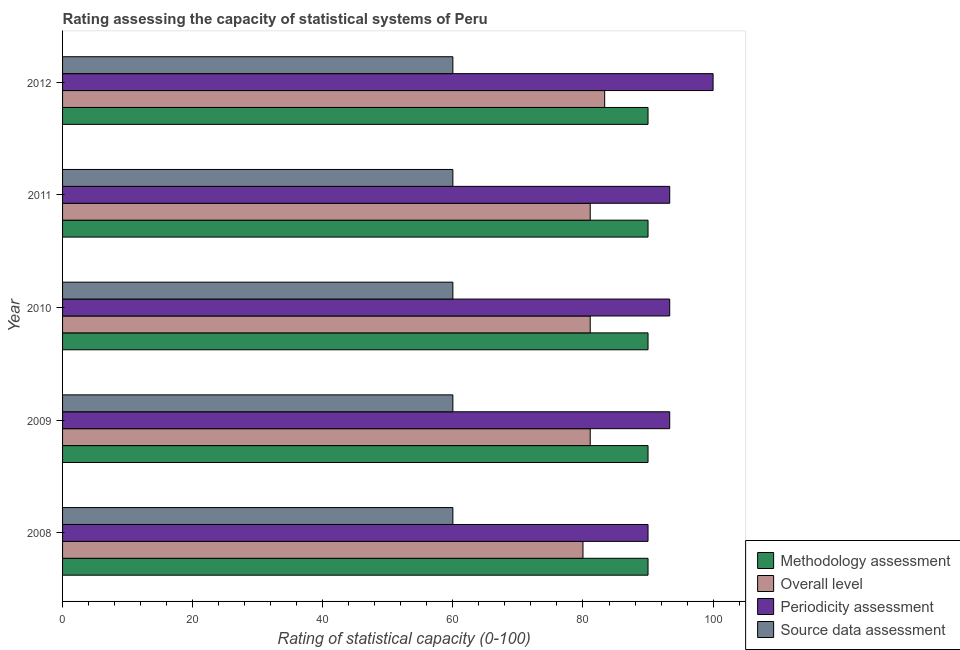How many groups of bars are there?
Ensure brevity in your answer.  5. Are the number of bars per tick equal to the number of legend labels?
Provide a short and direct response. Yes. How many bars are there on the 2nd tick from the top?
Ensure brevity in your answer.  4. How many bars are there on the 4th tick from the bottom?
Ensure brevity in your answer.  4. Across all years, what is the maximum methodology assessment rating?
Your response must be concise. 90. Across all years, what is the minimum methodology assessment rating?
Provide a succinct answer. 90. In which year was the overall level rating minimum?
Your response must be concise. 2008. What is the total periodicity assessment rating in the graph?
Offer a very short reply. 470. What is the difference between the methodology assessment rating in 2009 and that in 2012?
Make the answer very short. 0. What is the difference between the source data assessment rating in 2011 and the periodicity assessment rating in 2009?
Give a very brief answer. -33.33. In the year 2009, what is the difference between the periodicity assessment rating and overall level rating?
Your answer should be very brief. 12.22. What is the ratio of the overall level rating in 2010 to that in 2011?
Provide a short and direct response. 1. What is the difference between the highest and the second highest overall level rating?
Your answer should be very brief. 2.22. What is the difference between the highest and the lowest periodicity assessment rating?
Give a very brief answer. 10. In how many years, is the overall level rating greater than the average overall level rating taken over all years?
Keep it short and to the point. 1. Is the sum of the overall level rating in 2008 and 2011 greater than the maximum periodicity assessment rating across all years?
Your answer should be compact. Yes. What does the 3rd bar from the top in 2012 represents?
Provide a short and direct response. Overall level. What does the 2nd bar from the bottom in 2011 represents?
Offer a very short reply. Overall level. How many bars are there?
Ensure brevity in your answer.  20. Are all the bars in the graph horizontal?
Your answer should be very brief. Yes. What is the difference between two consecutive major ticks on the X-axis?
Keep it short and to the point. 20. Does the graph contain grids?
Your response must be concise. No. How many legend labels are there?
Offer a terse response. 4. What is the title of the graph?
Offer a terse response. Rating assessing the capacity of statistical systems of Peru. What is the label or title of the X-axis?
Give a very brief answer. Rating of statistical capacity (0-100). What is the label or title of the Y-axis?
Offer a terse response. Year. What is the Rating of statistical capacity (0-100) in Overall level in 2008?
Your answer should be compact. 80. What is the Rating of statistical capacity (0-100) of Periodicity assessment in 2008?
Your answer should be compact. 90. What is the Rating of statistical capacity (0-100) of Methodology assessment in 2009?
Provide a short and direct response. 90. What is the Rating of statistical capacity (0-100) of Overall level in 2009?
Give a very brief answer. 81.11. What is the Rating of statistical capacity (0-100) of Periodicity assessment in 2009?
Your answer should be very brief. 93.33. What is the Rating of statistical capacity (0-100) in Source data assessment in 2009?
Your response must be concise. 60. What is the Rating of statistical capacity (0-100) in Overall level in 2010?
Offer a terse response. 81.11. What is the Rating of statistical capacity (0-100) in Periodicity assessment in 2010?
Provide a short and direct response. 93.33. What is the Rating of statistical capacity (0-100) in Source data assessment in 2010?
Your response must be concise. 60. What is the Rating of statistical capacity (0-100) of Methodology assessment in 2011?
Offer a terse response. 90. What is the Rating of statistical capacity (0-100) of Overall level in 2011?
Offer a very short reply. 81.11. What is the Rating of statistical capacity (0-100) of Periodicity assessment in 2011?
Give a very brief answer. 93.33. What is the Rating of statistical capacity (0-100) of Source data assessment in 2011?
Give a very brief answer. 60. What is the Rating of statistical capacity (0-100) of Methodology assessment in 2012?
Give a very brief answer. 90. What is the Rating of statistical capacity (0-100) in Overall level in 2012?
Your answer should be compact. 83.33. What is the Rating of statistical capacity (0-100) of Periodicity assessment in 2012?
Your answer should be compact. 100. Across all years, what is the maximum Rating of statistical capacity (0-100) of Methodology assessment?
Give a very brief answer. 90. Across all years, what is the maximum Rating of statistical capacity (0-100) in Overall level?
Keep it short and to the point. 83.33. Across all years, what is the maximum Rating of statistical capacity (0-100) of Periodicity assessment?
Offer a very short reply. 100. Across all years, what is the maximum Rating of statistical capacity (0-100) in Source data assessment?
Keep it short and to the point. 60. Across all years, what is the minimum Rating of statistical capacity (0-100) in Periodicity assessment?
Offer a very short reply. 90. What is the total Rating of statistical capacity (0-100) in Methodology assessment in the graph?
Offer a very short reply. 450. What is the total Rating of statistical capacity (0-100) in Overall level in the graph?
Make the answer very short. 406.67. What is the total Rating of statistical capacity (0-100) in Periodicity assessment in the graph?
Offer a very short reply. 470. What is the total Rating of statistical capacity (0-100) of Source data assessment in the graph?
Your answer should be very brief. 300. What is the difference between the Rating of statistical capacity (0-100) of Overall level in 2008 and that in 2009?
Your answer should be compact. -1.11. What is the difference between the Rating of statistical capacity (0-100) of Periodicity assessment in 2008 and that in 2009?
Your answer should be very brief. -3.33. What is the difference between the Rating of statistical capacity (0-100) of Methodology assessment in 2008 and that in 2010?
Provide a succinct answer. 0. What is the difference between the Rating of statistical capacity (0-100) in Overall level in 2008 and that in 2010?
Offer a very short reply. -1.11. What is the difference between the Rating of statistical capacity (0-100) of Overall level in 2008 and that in 2011?
Offer a very short reply. -1.11. What is the difference between the Rating of statistical capacity (0-100) in Periodicity assessment in 2008 and that in 2011?
Your answer should be compact. -3.33. What is the difference between the Rating of statistical capacity (0-100) of Methodology assessment in 2008 and that in 2012?
Provide a succinct answer. 0. What is the difference between the Rating of statistical capacity (0-100) of Overall level in 2008 and that in 2012?
Provide a succinct answer. -3.33. What is the difference between the Rating of statistical capacity (0-100) in Periodicity assessment in 2008 and that in 2012?
Make the answer very short. -10. What is the difference between the Rating of statistical capacity (0-100) in Overall level in 2009 and that in 2010?
Keep it short and to the point. 0. What is the difference between the Rating of statistical capacity (0-100) of Methodology assessment in 2009 and that in 2011?
Offer a very short reply. 0. What is the difference between the Rating of statistical capacity (0-100) in Source data assessment in 2009 and that in 2011?
Your answer should be very brief. 0. What is the difference between the Rating of statistical capacity (0-100) in Overall level in 2009 and that in 2012?
Your response must be concise. -2.22. What is the difference between the Rating of statistical capacity (0-100) of Periodicity assessment in 2009 and that in 2012?
Make the answer very short. -6.67. What is the difference between the Rating of statistical capacity (0-100) in Methodology assessment in 2010 and that in 2011?
Make the answer very short. 0. What is the difference between the Rating of statistical capacity (0-100) in Overall level in 2010 and that in 2011?
Your answer should be compact. 0. What is the difference between the Rating of statistical capacity (0-100) of Overall level in 2010 and that in 2012?
Provide a succinct answer. -2.22. What is the difference between the Rating of statistical capacity (0-100) of Periodicity assessment in 2010 and that in 2012?
Keep it short and to the point. -6.67. What is the difference between the Rating of statistical capacity (0-100) in Methodology assessment in 2011 and that in 2012?
Ensure brevity in your answer.  0. What is the difference between the Rating of statistical capacity (0-100) of Overall level in 2011 and that in 2012?
Your answer should be very brief. -2.22. What is the difference between the Rating of statistical capacity (0-100) of Periodicity assessment in 2011 and that in 2012?
Provide a succinct answer. -6.67. What is the difference between the Rating of statistical capacity (0-100) of Methodology assessment in 2008 and the Rating of statistical capacity (0-100) of Overall level in 2009?
Offer a terse response. 8.89. What is the difference between the Rating of statistical capacity (0-100) of Methodology assessment in 2008 and the Rating of statistical capacity (0-100) of Periodicity assessment in 2009?
Provide a short and direct response. -3.33. What is the difference between the Rating of statistical capacity (0-100) of Methodology assessment in 2008 and the Rating of statistical capacity (0-100) of Source data assessment in 2009?
Your answer should be compact. 30. What is the difference between the Rating of statistical capacity (0-100) in Overall level in 2008 and the Rating of statistical capacity (0-100) in Periodicity assessment in 2009?
Provide a short and direct response. -13.33. What is the difference between the Rating of statistical capacity (0-100) in Overall level in 2008 and the Rating of statistical capacity (0-100) in Source data assessment in 2009?
Give a very brief answer. 20. What is the difference between the Rating of statistical capacity (0-100) of Periodicity assessment in 2008 and the Rating of statistical capacity (0-100) of Source data assessment in 2009?
Your response must be concise. 30. What is the difference between the Rating of statistical capacity (0-100) of Methodology assessment in 2008 and the Rating of statistical capacity (0-100) of Overall level in 2010?
Ensure brevity in your answer.  8.89. What is the difference between the Rating of statistical capacity (0-100) of Methodology assessment in 2008 and the Rating of statistical capacity (0-100) of Periodicity assessment in 2010?
Keep it short and to the point. -3.33. What is the difference between the Rating of statistical capacity (0-100) in Overall level in 2008 and the Rating of statistical capacity (0-100) in Periodicity assessment in 2010?
Offer a very short reply. -13.33. What is the difference between the Rating of statistical capacity (0-100) in Overall level in 2008 and the Rating of statistical capacity (0-100) in Source data assessment in 2010?
Offer a terse response. 20. What is the difference between the Rating of statistical capacity (0-100) of Periodicity assessment in 2008 and the Rating of statistical capacity (0-100) of Source data assessment in 2010?
Provide a short and direct response. 30. What is the difference between the Rating of statistical capacity (0-100) in Methodology assessment in 2008 and the Rating of statistical capacity (0-100) in Overall level in 2011?
Your answer should be compact. 8.89. What is the difference between the Rating of statistical capacity (0-100) in Overall level in 2008 and the Rating of statistical capacity (0-100) in Periodicity assessment in 2011?
Keep it short and to the point. -13.33. What is the difference between the Rating of statistical capacity (0-100) in Methodology assessment in 2008 and the Rating of statistical capacity (0-100) in Periodicity assessment in 2012?
Make the answer very short. -10. What is the difference between the Rating of statistical capacity (0-100) of Overall level in 2008 and the Rating of statistical capacity (0-100) of Source data assessment in 2012?
Offer a terse response. 20. What is the difference between the Rating of statistical capacity (0-100) of Periodicity assessment in 2008 and the Rating of statistical capacity (0-100) of Source data assessment in 2012?
Make the answer very short. 30. What is the difference between the Rating of statistical capacity (0-100) of Methodology assessment in 2009 and the Rating of statistical capacity (0-100) of Overall level in 2010?
Give a very brief answer. 8.89. What is the difference between the Rating of statistical capacity (0-100) of Methodology assessment in 2009 and the Rating of statistical capacity (0-100) of Source data assessment in 2010?
Your response must be concise. 30. What is the difference between the Rating of statistical capacity (0-100) of Overall level in 2009 and the Rating of statistical capacity (0-100) of Periodicity assessment in 2010?
Give a very brief answer. -12.22. What is the difference between the Rating of statistical capacity (0-100) in Overall level in 2009 and the Rating of statistical capacity (0-100) in Source data assessment in 2010?
Your answer should be compact. 21.11. What is the difference between the Rating of statistical capacity (0-100) in Periodicity assessment in 2009 and the Rating of statistical capacity (0-100) in Source data assessment in 2010?
Make the answer very short. 33.33. What is the difference between the Rating of statistical capacity (0-100) in Methodology assessment in 2009 and the Rating of statistical capacity (0-100) in Overall level in 2011?
Your answer should be compact. 8.89. What is the difference between the Rating of statistical capacity (0-100) of Overall level in 2009 and the Rating of statistical capacity (0-100) of Periodicity assessment in 2011?
Offer a very short reply. -12.22. What is the difference between the Rating of statistical capacity (0-100) in Overall level in 2009 and the Rating of statistical capacity (0-100) in Source data assessment in 2011?
Your answer should be compact. 21.11. What is the difference between the Rating of statistical capacity (0-100) of Periodicity assessment in 2009 and the Rating of statistical capacity (0-100) of Source data assessment in 2011?
Offer a very short reply. 33.33. What is the difference between the Rating of statistical capacity (0-100) of Methodology assessment in 2009 and the Rating of statistical capacity (0-100) of Overall level in 2012?
Give a very brief answer. 6.67. What is the difference between the Rating of statistical capacity (0-100) of Overall level in 2009 and the Rating of statistical capacity (0-100) of Periodicity assessment in 2012?
Your response must be concise. -18.89. What is the difference between the Rating of statistical capacity (0-100) of Overall level in 2009 and the Rating of statistical capacity (0-100) of Source data assessment in 2012?
Provide a short and direct response. 21.11. What is the difference between the Rating of statistical capacity (0-100) in Periodicity assessment in 2009 and the Rating of statistical capacity (0-100) in Source data assessment in 2012?
Provide a short and direct response. 33.33. What is the difference between the Rating of statistical capacity (0-100) in Methodology assessment in 2010 and the Rating of statistical capacity (0-100) in Overall level in 2011?
Your answer should be compact. 8.89. What is the difference between the Rating of statistical capacity (0-100) in Overall level in 2010 and the Rating of statistical capacity (0-100) in Periodicity assessment in 2011?
Keep it short and to the point. -12.22. What is the difference between the Rating of statistical capacity (0-100) in Overall level in 2010 and the Rating of statistical capacity (0-100) in Source data assessment in 2011?
Your response must be concise. 21.11. What is the difference between the Rating of statistical capacity (0-100) of Periodicity assessment in 2010 and the Rating of statistical capacity (0-100) of Source data assessment in 2011?
Your answer should be very brief. 33.33. What is the difference between the Rating of statistical capacity (0-100) of Methodology assessment in 2010 and the Rating of statistical capacity (0-100) of Overall level in 2012?
Offer a terse response. 6.67. What is the difference between the Rating of statistical capacity (0-100) of Methodology assessment in 2010 and the Rating of statistical capacity (0-100) of Periodicity assessment in 2012?
Give a very brief answer. -10. What is the difference between the Rating of statistical capacity (0-100) of Overall level in 2010 and the Rating of statistical capacity (0-100) of Periodicity assessment in 2012?
Ensure brevity in your answer.  -18.89. What is the difference between the Rating of statistical capacity (0-100) of Overall level in 2010 and the Rating of statistical capacity (0-100) of Source data assessment in 2012?
Your answer should be very brief. 21.11. What is the difference between the Rating of statistical capacity (0-100) in Periodicity assessment in 2010 and the Rating of statistical capacity (0-100) in Source data assessment in 2012?
Ensure brevity in your answer.  33.33. What is the difference between the Rating of statistical capacity (0-100) in Methodology assessment in 2011 and the Rating of statistical capacity (0-100) in Overall level in 2012?
Provide a succinct answer. 6.67. What is the difference between the Rating of statistical capacity (0-100) in Methodology assessment in 2011 and the Rating of statistical capacity (0-100) in Periodicity assessment in 2012?
Make the answer very short. -10. What is the difference between the Rating of statistical capacity (0-100) of Methodology assessment in 2011 and the Rating of statistical capacity (0-100) of Source data assessment in 2012?
Your response must be concise. 30. What is the difference between the Rating of statistical capacity (0-100) of Overall level in 2011 and the Rating of statistical capacity (0-100) of Periodicity assessment in 2012?
Give a very brief answer. -18.89. What is the difference between the Rating of statistical capacity (0-100) in Overall level in 2011 and the Rating of statistical capacity (0-100) in Source data assessment in 2012?
Offer a very short reply. 21.11. What is the difference between the Rating of statistical capacity (0-100) of Periodicity assessment in 2011 and the Rating of statistical capacity (0-100) of Source data assessment in 2012?
Give a very brief answer. 33.33. What is the average Rating of statistical capacity (0-100) in Overall level per year?
Your answer should be very brief. 81.33. What is the average Rating of statistical capacity (0-100) of Periodicity assessment per year?
Ensure brevity in your answer.  94. What is the average Rating of statistical capacity (0-100) of Source data assessment per year?
Offer a very short reply. 60. In the year 2009, what is the difference between the Rating of statistical capacity (0-100) of Methodology assessment and Rating of statistical capacity (0-100) of Overall level?
Ensure brevity in your answer.  8.89. In the year 2009, what is the difference between the Rating of statistical capacity (0-100) of Methodology assessment and Rating of statistical capacity (0-100) of Periodicity assessment?
Give a very brief answer. -3.33. In the year 2009, what is the difference between the Rating of statistical capacity (0-100) in Overall level and Rating of statistical capacity (0-100) in Periodicity assessment?
Offer a terse response. -12.22. In the year 2009, what is the difference between the Rating of statistical capacity (0-100) of Overall level and Rating of statistical capacity (0-100) of Source data assessment?
Ensure brevity in your answer.  21.11. In the year 2009, what is the difference between the Rating of statistical capacity (0-100) in Periodicity assessment and Rating of statistical capacity (0-100) in Source data assessment?
Your answer should be very brief. 33.33. In the year 2010, what is the difference between the Rating of statistical capacity (0-100) in Methodology assessment and Rating of statistical capacity (0-100) in Overall level?
Your answer should be very brief. 8.89. In the year 2010, what is the difference between the Rating of statistical capacity (0-100) in Overall level and Rating of statistical capacity (0-100) in Periodicity assessment?
Ensure brevity in your answer.  -12.22. In the year 2010, what is the difference between the Rating of statistical capacity (0-100) of Overall level and Rating of statistical capacity (0-100) of Source data assessment?
Your response must be concise. 21.11. In the year 2010, what is the difference between the Rating of statistical capacity (0-100) in Periodicity assessment and Rating of statistical capacity (0-100) in Source data assessment?
Keep it short and to the point. 33.33. In the year 2011, what is the difference between the Rating of statistical capacity (0-100) in Methodology assessment and Rating of statistical capacity (0-100) in Overall level?
Offer a very short reply. 8.89. In the year 2011, what is the difference between the Rating of statistical capacity (0-100) in Methodology assessment and Rating of statistical capacity (0-100) in Periodicity assessment?
Offer a very short reply. -3.33. In the year 2011, what is the difference between the Rating of statistical capacity (0-100) of Overall level and Rating of statistical capacity (0-100) of Periodicity assessment?
Keep it short and to the point. -12.22. In the year 2011, what is the difference between the Rating of statistical capacity (0-100) of Overall level and Rating of statistical capacity (0-100) of Source data assessment?
Ensure brevity in your answer.  21.11. In the year 2011, what is the difference between the Rating of statistical capacity (0-100) of Periodicity assessment and Rating of statistical capacity (0-100) of Source data assessment?
Your response must be concise. 33.33. In the year 2012, what is the difference between the Rating of statistical capacity (0-100) in Methodology assessment and Rating of statistical capacity (0-100) in Periodicity assessment?
Your response must be concise. -10. In the year 2012, what is the difference between the Rating of statistical capacity (0-100) in Overall level and Rating of statistical capacity (0-100) in Periodicity assessment?
Provide a short and direct response. -16.67. In the year 2012, what is the difference between the Rating of statistical capacity (0-100) in Overall level and Rating of statistical capacity (0-100) in Source data assessment?
Keep it short and to the point. 23.33. What is the ratio of the Rating of statistical capacity (0-100) of Methodology assessment in 2008 to that in 2009?
Provide a short and direct response. 1. What is the ratio of the Rating of statistical capacity (0-100) in Overall level in 2008 to that in 2009?
Offer a very short reply. 0.99. What is the ratio of the Rating of statistical capacity (0-100) in Source data assessment in 2008 to that in 2009?
Keep it short and to the point. 1. What is the ratio of the Rating of statistical capacity (0-100) in Overall level in 2008 to that in 2010?
Make the answer very short. 0.99. What is the ratio of the Rating of statistical capacity (0-100) in Periodicity assessment in 2008 to that in 2010?
Make the answer very short. 0.96. What is the ratio of the Rating of statistical capacity (0-100) in Methodology assessment in 2008 to that in 2011?
Your response must be concise. 1. What is the ratio of the Rating of statistical capacity (0-100) in Overall level in 2008 to that in 2011?
Your answer should be very brief. 0.99. What is the ratio of the Rating of statistical capacity (0-100) in Periodicity assessment in 2008 to that in 2011?
Keep it short and to the point. 0.96. What is the ratio of the Rating of statistical capacity (0-100) in Methodology assessment in 2009 to that in 2010?
Your answer should be very brief. 1. What is the ratio of the Rating of statistical capacity (0-100) of Periodicity assessment in 2009 to that in 2010?
Offer a very short reply. 1. What is the ratio of the Rating of statistical capacity (0-100) in Methodology assessment in 2009 to that in 2011?
Keep it short and to the point. 1. What is the ratio of the Rating of statistical capacity (0-100) of Periodicity assessment in 2009 to that in 2011?
Provide a short and direct response. 1. What is the ratio of the Rating of statistical capacity (0-100) in Overall level in 2009 to that in 2012?
Make the answer very short. 0.97. What is the ratio of the Rating of statistical capacity (0-100) in Periodicity assessment in 2009 to that in 2012?
Make the answer very short. 0.93. What is the ratio of the Rating of statistical capacity (0-100) in Source data assessment in 2009 to that in 2012?
Offer a very short reply. 1. What is the ratio of the Rating of statistical capacity (0-100) of Overall level in 2010 to that in 2011?
Provide a short and direct response. 1. What is the ratio of the Rating of statistical capacity (0-100) of Methodology assessment in 2010 to that in 2012?
Provide a succinct answer. 1. What is the ratio of the Rating of statistical capacity (0-100) of Overall level in 2010 to that in 2012?
Keep it short and to the point. 0.97. What is the ratio of the Rating of statistical capacity (0-100) in Source data assessment in 2010 to that in 2012?
Your answer should be compact. 1. What is the ratio of the Rating of statistical capacity (0-100) of Overall level in 2011 to that in 2012?
Your response must be concise. 0.97. What is the difference between the highest and the second highest Rating of statistical capacity (0-100) of Methodology assessment?
Offer a terse response. 0. What is the difference between the highest and the second highest Rating of statistical capacity (0-100) in Overall level?
Give a very brief answer. 2.22. What is the difference between the highest and the second highest Rating of statistical capacity (0-100) of Periodicity assessment?
Ensure brevity in your answer.  6.67. What is the difference between the highest and the lowest Rating of statistical capacity (0-100) in Methodology assessment?
Your answer should be compact. 0. What is the difference between the highest and the lowest Rating of statistical capacity (0-100) in Overall level?
Provide a succinct answer. 3.33. What is the difference between the highest and the lowest Rating of statistical capacity (0-100) in Periodicity assessment?
Make the answer very short. 10. What is the difference between the highest and the lowest Rating of statistical capacity (0-100) of Source data assessment?
Ensure brevity in your answer.  0. 